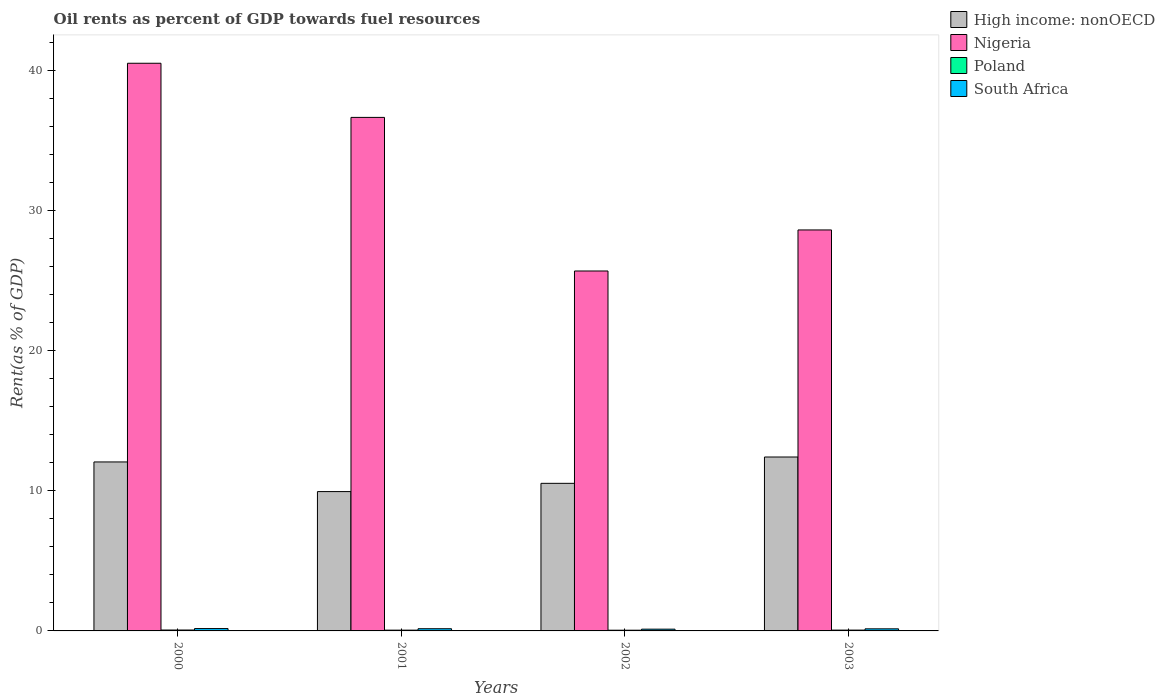How many different coloured bars are there?
Keep it short and to the point. 4. How many bars are there on the 4th tick from the left?
Make the answer very short. 4. How many bars are there on the 1st tick from the right?
Your answer should be compact. 4. In how many cases, is the number of bars for a given year not equal to the number of legend labels?
Your response must be concise. 0. What is the oil rent in South Africa in 2000?
Offer a terse response. 0.17. Across all years, what is the maximum oil rent in Nigeria?
Ensure brevity in your answer.  40.49. Across all years, what is the minimum oil rent in Poland?
Make the answer very short. 0.05. In which year was the oil rent in High income: nonOECD minimum?
Provide a succinct answer. 2001. What is the total oil rent in Nigeria in the graph?
Ensure brevity in your answer.  131.39. What is the difference between the oil rent in South Africa in 2001 and that in 2002?
Your response must be concise. 0.03. What is the difference between the oil rent in South Africa in 2000 and the oil rent in High income: nonOECD in 2001?
Offer a very short reply. -9.77. What is the average oil rent in Nigeria per year?
Provide a short and direct response. 32.85. In the year 2003, what is the difference between the oil rent in High income: nonOECD and oil rent in Poland?
Your response must be concise. 12.35. In how many years, is the oil rent in Nigeria greater than 38 %?
Your answer should be very brief. 1. What is the ratio of the oil rent in South Africa in 2001 to that in 2003?
Give a very brief answer. 1.05. Is the oil rent in Poland in 2002 less than that in 2003?
Your response must be concise. Yes. What is the difference between the highest and the second highest oil rent in South Africa?
Provide a short and direct response. 0.01. What is the difference between the highest and the lowest oil rent in South Africa?
Provide a short and direct response. 0.04. In how many years, is the oil rent in South Africa greater than the average oil rent in South Africa taken over all years?
Your answer should be very brief. 2. Is the sum of the oil rent in Poland in 2000 and 2001 greater than the maximum oil rent in Nigeria across all years?
Your answer should be compact. No. What does the 1st bar from the left in 2001 represents?
Provide a short and direct response. High income: nonOECD. Is it the case that in every year, the sum of the oil rent in South Africa and oil rent in High income: nonOECD is greater than the oil rent in Poland?
Your answer should be very brief. Yes. How many years are there in the graph?
Make the answer very short. 4. What is the difference between two consecutive major ticks on the Y-axis?
Your answer should be very brief. 10. Are the values on the major ticks of Y-axis written in scientific E-notation?
Offer a terse response. No. How many legend labels are there?
Make the answer very short. 4. What is the title of the graph?
Provide a short and direct response. Oil rents as percent of GDP towards fuel resources. What is the label or title of the Y-axis?
Offer a terse response. Rent(as % of GDP). What is the Rent(as % of GDP) of High income: nonOECD in 2000?
Give a very brief answer. 12.05. What is the Rent(as % of GDP) in Nigeria in 2000?
Give a very brief answer. 40.49. What is the Rent(as % of GDP) of Poland in 2000?
Offer a very short reply. 0.06. What is the Rent(as % of GDP) in South Africa in 2000?
Offer a terse response. 0.17. What is the Rent(as % of GDP) of High income: nonOECD in 2001?
Provide a succinct answer. 9.94. What is the Rent(as % of GDP) in Nigeria in 2001?
Provide a succinct answer. 36.63. What is the Rent(as % of GDP) in Poland in 2001?
Offer a very short reply. 0.05. What is the Rent(as % of GDP) of South Africa in 2001?
Your answer should be very brief. 0.16. What is the Rent(as % of GDP) of High income: nonOECD in 2002?
Offer a very short reply. 10.53. What is the Rent(as % of GDP) in Nigeria in 2002?
Offer a terse response. 25.67. What is the Rent(as % of GDP) in Poland in 2002?
Provide a succinct answer. 0.05. What is the Rent(as % of GDP) in South Africa in 2002?
Your answer should be very brief. 0.13. What is the Rent(as % of GDP) in High income: nonOECD in 2003?
Your answer should be very brief. 12.4. What is the Rent(as % of GDP) in Nigeria in 2003?
Your answer should be very brief. 28.6. What is the Rent(as % of GDP) of Poland in 2003?
Offer a very short reply. 0.06. What is the Rent(as % of GDP) in South Africa in 2003?
Your answer should be compact. 0.15. Across all years, what is the maximum Rent(as % of GDP) in High income: nonOECD?
Keep it short and to the point. 12.4. Across all years, what is the maximum Rent(as % of GDP) in Nigeria?
Provide a short and direct response. 40.49. Across all years, what is the maximum Rent(as % of GDP) of Poland?
Ensure brevity in your answer.  0.06. Across all years, what is the maximum Rent(as % of GDP) in South Africa?
Provide a succinct answer. 0.17. Across all years, what is the minimum Rent(as % of GDP) in High income: nonOECD?
Provide a succinct answer. 9.94. Across all years, what is the minimum Rent(as % of GDP) of Nigeria?
Give a very brief answer. 25.67. Across all years, what is the minimum Rent(as % of GDP) of Poland?
Your answer should be very brief. 0.05. Across all years, what is the minimum Rent(as % of GDP) of South Africa?
Provide a short and direct response. 0.13. What is the total Rent(as % of GDP) of High income: nonOECD in the graph?
Your answer should be very brief. 44.92. What is the total Rent(as % of GDP) in Nigeria in the graph?
Your response must be concise. 131.39. What is the total Rent(as % of GDP) in Poland in the graph?
Make the answer very short. 0.23. What is the total Rent(as % of GDP) of South Africa in the graph?
Your answer should be compact. 0.6. What is the difference between the Rent(as % of GDP) of High income: nonOECD in 2000 and that in 2001?
Offer a very short reply. 2.11. What is the difference between the Rent(as % of GDP) of Nigeria in 2000 and that in 2001?
Give a very brief answer. 3.86. What is the difference between the Rent(as % of GDP) of Poland in 2000 and that in 2001?
Your answer should be very brief. 0.01. What is the difference between the Rent(as % of GDP) in South Africa in 2000 and that in 2001?
Provide a short and direct response. 0.01. What is the difference between the Rent(as % of GDP) in High income: nonOECD in 2000 and that in 2002?
Your response must be concise. 1.53. What is the difference between the Rent(as % of GDP) in Nigeria in 2000 and that in 2002?
Offer a very short reply. 14.82. What is the difference between the Rent(as % of GDP) in Poland in 2000 and that in 2002?
Your answer should be compact. 0.01. What is the difference between the Rent(as % of GDP) of South Africa in 2000 and that in 2002?
Ensure brevity in your answer.  0.04. What is the difference between the Rent(as % of GDP) of High income: nonOECD in 2000 and that in 2003?
Provide a short and direct response. -0.35. What is the difference between the Rent(as % of GDP) in Nigeria in 2000 and that in 2003?
Offer a terse response. 11.89. What is the difference between the Rent(as % of GDP) in Poland in 2000 and that in 2003?
Provide a succinct answer. 0.01. What is the difference between the Rent(as % of GDP) of South Africa in 2000 and that in 2003?
Keep it short and to the point. 0.02. What is the difference between the Rent(as % of GDP) of High income: nonOECD in 2001 and that in 2002?
Your answer should be very brief. -0.59. What is the difference between the Rent(as % of GDP) in Nigeria in 2001 and that in 2002?
Ensure brevity in your answer.  10.95. What is the difference between the Rent(as % of GDP) in Poland in 2001 and that in 2002?
Provide a short and direct response. 0. What is the difference between the Rent(as % of GDP) in South Africa in 2001 and that in 2002?
Keep it short and to the point. 0.03. What is the difference between the Rent(as % of GDP) in High income: nonOECD in 2001 and that in 2003?
Ensure brevity in your answer.  -2.47. What is the difference between the Rent(as % of GDP) in Nigeria in 2001 and that in 2003?
Give a very brief answer. 8.03. What is the difference between the Rent(as % of GDP) in Poland in 2001 and that in 2003?
Ensure brevity in your answer.  -0. What is the difference between the Rent(as % of GDP) of South Africa in 2001 and that in 2003?
Provide a short and direct response. 0.01. What is the difference between the Rent(as % of GDP) in High income: nonOECD in 2002 and that in 2003?
Your response must be concise. -1.88. What is the difference between the Rent(as % of GDP) of Nigeria in 2002 and that in 2003?
Ensure brevity in your answer.  -2.93. What is the difference between the Rent(as % of GDP) of Poland in 2002 and that in 2003?
Your answer should be compact. -0.01. What is the difference between the Rent(as % of GDP) in South Africa in 2002 and that in 2003?
Your response must be concise. -0.02. What is the difference between the Rent(as % of GDP) in High income: nonOECD in 2000 and the Rent(as % of GDP) in Nigeria in 2001?
Your answer should be very brief. -24.57. What is the difference between the Rent(as % of GDP) of High income: nonOECD in 2000 and the Rent(as % of GDP) of Poland in 2001?
Provide a short and direct response. 12. What is the difference between the Rent(as % of GDP) in High income: nonOECD in 2000 and the Rent(as % of GDP) in South Africa in 2001?
Make the answer very short. 11.9. What is the difference between the Rent(as % of GDP) in Nigeria in 2000 and the Rent(as % of GDP) in Poland in 2001?
Your answer should be compact. 40.43. What is the difference between the Rent(as % of GDP) in Nigeria in 2000 and the Rent(as % of GDP) in South Africa in 2001?
Keep it short and to the point. 40.33. What is the difference between the Rent(as % of GDP) of Poland in 2000 and the Rent(as % of GDP) of South Africa in 2001?
Provide a short and direct response. -0.09. What is the difference between the Rent(as % of GDP) of High income: nonOECD in 2000 and the Rent(as % of GDP) of Nigeria in 2002?
Your answer should be compact. -13.62. What is the difference between the Rent(as % of GDP) in High income: nonOECD in 2000 and the Rent(as % of GDP) in Poland in 2002?
Provide a succinct answer. 12. What is the difference between the Rent(as % of GDP) in High income: nonOECD in 2000 and the Rent(as % of GDP) in South Africa in 2002?
Your response must be concise. 11.93. What is the difference between the Rent(as % of GDP) of Nigeria in 2000 and the Rent(as % of GDP) of Poland in 2002?
Provide a succinct answer. 40.44. What is the difference between the Rent(as % of GDP) of Nigeria in 2000 and the Rent(as % of GDP) of South Africa in 2002?
Provide a short and direct response. 40.36. What is the difference between the Rent(as % of GDP) of Poland in 2000 and the Rent(as % of GDP) of South Africa in 2002?
Offer a very short reply. -0.06. What is the difference between the Rent(as % of GDP) in High income: nonOECD in 2000 and the Rent(as % of GDP) in Nigeria in 2003?
Your answer should be compact. -16.55. What is the difference between the Rent(as % of GDP) of High income: nonOECD in 2000 and the Rent(as % of GDP) of Poland in 2003?
Make the answer very short. 11.99. What is the difference between the Rent(as % of GDP) of High income: nonOECD in 2000 and the Rent(as % of GDP) of South Africa in 2003?
Offer a very short reply. 11.9. What is the difference between the Rent(as % of GDP) of Nigeria in 2000 and the Rent(as % of GDP) of Poland in 2003?
Your answer should be compact. 40.43. What is the difference between the Rent(as % of GDP) in Nigeria in 2000 and the Rent(as % of GDP) in South Africa in 2003?
Offer a terse response. 40.34. What is the difference between the Rent(as % of GDP) of Poland in 2000 and the Rent(as % of GDP) of South Africa in 2003?
Ensure brevity in your answer.  -0.09. What is the difference between the Rent(as % of GDP) in High income: nonOECD in 2001 and the Rent(as % of GDP) in Nigeria in 2002?
Offer a terse response. -15.73. What is the difference between the Rent(as % of GDP) of High income: nonOECD in 2001 and the Rent(as % of GDP) of Poland in 2002?
Give a very brief answer. 9.89. What is the difference between the Rent(as % of GDP) of High income: nonOECD in 2001 and the Rent(as % of GDP) of South Africa in 2002?
Provide a succinct answer. 9.81. What is the difference between the Rent(as % of GDP) of Nigeria in 2001 and the Rent(as % of GDP) of Poland in 2002?
Offer a very short reply. 36.58. What is the difference between the Rent(as % of GDP) of Nigeria in 2001 and the Rent(as % of GDP) of South Africa in 2002?
Provide a succinct answer. 36.5. What is the difference between the Rent(as % of GDP) of Poland in 2001 and the Rent(as % of GDP) of South Africa in 2002?
Give a very brief answer. -0.07. What is the difference between the Rent(as % of GDP) of High income: nonOECD in 2001 and the Rent(as % of GDP) of Nigeria in 2003?
Provide a succinct answer. -18.66. What is the difference between the Rent(as % of GDP) of High income: nonOECD in 2001 and the Rent(as % of GDP) of Poland in 2003?
Offer a very short reply. 9.88. What is the difference between the Rent(as % of GDP) in High income: nonOECD in 2001 and the Rent(as % of GDP) in South Africa in 2003?
Provide a succinct answer. 9.79. What is the difference between the Rent(as % of GDP) in Nigeria in 2001 and the Rent(as % of GDP) in Poland in 2003?
Give a very brief answer. 36.57. What is the difference between the Rent(as % of GDP) in Nigeria in 2001 and the Rent(as % of GDP) in South Africa in 2003?
Your answer should be very brief. 36.48. What is the difference between the Rent(as % of GDP) of Poland in 2001 and the Rent(as % of GDP) of South Africa in 2003?
Provide a short and direct response. -0.09. What is the difference between the Rent(as % of GDP) of High income: nonOECD in 2002 and the Rent(as % of GDP) of Nigeria in 2003?
Your answer should be compact. -18.07. What is the difference between the Rent(as % of GDP) in High income: nonOECD in 2002 and the Rent(as % of GDP) in Poland in 2003?
Provide a short and direct response. 10.47. What is the difference between the Rent(as % of GDP) in High income: nonOECD in 2002 and the Rent(as % of GDP) in South Africa in 2003?
Your answer should be compact. 10.38. What is the difference between the Rent(as % of GDP) of Nigeria in 2002 and the Rent(as % of GDP) of Poland in 2003?
Your answer should be compact. 25.61. What is the difference between the Rent(as % of GDP) in Nigeria in 2002 and the Rent(as % of GDP) in South Africa in 2003?
Provide a succinct answer. 25.52. What is the difference between the Rent(as % of GDP) of Poland in 2002 and the Rent(as % of GDP) of South Africa in 2003?
Your answer should be compact. -0.1. What is the average Rent(as % of GDP) in High income: nonOECD per year?
Your answer should be very brief. 11.23. What is the average Rent(as % of GDP) of Nigeria per year?
Ensure brevity in your answer.  32.85. What is the average Rent(as % of GDP) in Poland per year?
Offer a very short reply. 0.06. What is the average Rent(as % of GDP) of South Africa per year?
Your answer should be very brief. 0.15. In the year 2000, what is the difference between the Rent(as % of GDP) of High income: nonOECD and Rent(as % of GDP) of Nigeria?
Offer a very short reply. -28.44. In the year 2000, what is the difference between the Rent(as % of GDP) in High income: nonOECD and Rent(as % of GDP) in Poland?
Your response must be concise. 11.99. In the year 2000, what is the difference between the Rent(as % of GDP) of High income: nonOECD and Rent(as % of GDP) of South Africa?
Keep it short and to the point. 11.88. In the year 2000, what is the difference between the Rent(as % of GDP) of Nigeria and Rent(as % of GDP) of Poland?
Offer a terse response. 40.42. In the year 2000, what is the difference between the Rent(as % of GDP) in Nigeria and Rent(as % of GDP) in South Africa?
Ensure brevity in your answer.  40.32. In the year 2000, what is the difference between the Rent(as % of GDP) in Poland and Rent(as % of GDP) in South Africa?
Provide a succinct answer. -0.1. In the year 2001, what is the difference between the Rent(as % of GDP) of High income: nonOECD and Rent(as % of GDP) of Nigeria?
Give a very brief answer. -26.69. In the year 2001, what is the difference between the Rent(as % of GDP) of High income: nonOECD and Rent(as % of GDP) of Poland?
Provide a short and direct response. 9.88. In the year 2001, what is the difference between the Rent(as % of GDP) in High income: nonOECD and Rent(as % of GDP) in South Africa?
Your answer should be very brief. 9.78. In the year 2001, what is the difference between the Rent(as % of GDP) in Nigeria and Rent(as % of GDP) in Poland?
Offer a very short reply. 36.57. In the year 2001, what is the difference between the Rent(as % of GDP) of Nigeria and Rent(as % of GDP) of South Africa?
Your response must be concise. 36.47. In the year 2001, what is the difference between the Rent(as % of GDP) of Poland and Rent(as % of GDP) of South Africa?
Keep it short and to the point. -0.1. In the year 2002, what is the difference between the Rent(as % of GDP) of High income: nonOECD and Rent(as % of GDP) of Nigeria?
Give a very brief answer. -15.15. In the year 2002, what is the difference between the Rent(as % of GDP) in High income: nonOECD and Rent(as % of GDP) in Poland?
Give a very brief answer. 10.48. In the year 2002, what is the difference between the Rent(as % of GDP) of High income: nonOECD and Rent(as % of GDP) of South Africa?
Your answer should be compact. 10.4. In the year 2002, what is the difference between the Rent(as % of GDP) of Nigeria and Rent(as % of GDP) of Poland?
Provide a short and direct response. 25.62. In the year 2002, what is the difference between the Rent(as % of GDP) in Nigeria and Rent(as % of GDP) in South Africa?
Offer a very short reply. 25.55. In the year 2002, what is the difference between the Rent(as % of GDP) in Poland and Rent(as % of GDP) in South Africa?
Your response must be concise. -0.07. In the year 2003, what is the difference between the Rent(as % of GDP) of High income: nonOECD and Rent(as % of GDP) of Nigeria?
Give a very brief answer. -16.19. In the year 2003, what is the difference between the Rent(as % of GDP) in High income: nonOECD and Rent(as % of GDP) in Poland?
Offer a terse response. 12.35. In the year 2003, what is the difference between the Rent(as % of GDP) in High income: nonOECD and Rent(as % of GDP) in South Africa?
Provide a short and direct response. 12.26. In the year 2003, what is the difference between the Rent(as % of GDP) in Nigeria and Rent(as % of GDP) in Poland?
Offer a very short reply. 28.54. In the year 2003, what is the difference between the Rent(as % of GDP) of Nigeria and Rent(as % of GDP) of South Africa?
Provide a succinct answer. 28.45. In the year 2003, what is the difference between the Rent(as % of GDP) in Poland and Rent(as % of GDP) in South Africa?
Offer a terse response. -0.09. What is the ratio of the Rent(as % of GDP) of High income: nonOECD in 2000 to that in 2001?
Your answer should be compact. 1.21. What is the ratio of the Rent(as % of GDP) in Nigeria in 2000 to that in 2001?
Provide a succinct answer. 1.11. What is the ratio of the Rent(as % of GDP) in Poland in 2000 to that in 2001?
Offer a very short reply. 1.16. What is the ratio of the Rent(as % of GDP) of South Africa in 2000 to that in 2001?
Your response must be concise. 1.07. What is the ratio of the Rent(as % of GDP) in High income: nonOECD in 2000 to that in 2002?
Your response must be concise. 1.14. What is the ratio of the Rent(as % of GDP) of Nigeria in 2000 to that in 2002?
Offer a very short reply. 1.58. What is the ratio of the Rent(as % of GDP) of Poland in 2000 to that in 2002?
Make the answer very short. 1.25. What is the ratio of the Rent(as % of GDP) in South Africa in 2000 to that in 2002?
Your answer should be compact. 1.34. What is the ratio of the Rent(as % of GDP) of High income: nonOECD in 2000 to that in 2003?
Your answer should be compact. 0.97. What is the ratio of the Rent(as % of GDP) of Nigeria in 2000 to that in 2003?
Provide a succinct answer. 1.42. What is the ratio of the Rent(as % of GDP) in Poland in 2000 to that in 2003?
Ensure brevity in your answer.  1.09. What is the ratio of the Rent(as % of GDP) of South Africa in 2000 to that in 2003?
Make the answer very short. 1.13. What is the ratio of the Rent(as % of GDP) of High income: nonOECD in 2001 to that in 2002?
Your answer should be very brief. 0.94. What is the ratio of the Rent(as % of GDP) in Nigeria in 2001 to that in 2002?
Make the answer very short. 1.43. What is the ratio of the Rent(as % of GDP) of Poland in 2001 to that in 2002?
Your answer should be very brief. 1.08. What is the ratio of the Rent(as % of GDP) in South Africa in 2001 to that in 2002?
Your answer should be compact. 1.25. What is the ratio of the Rent(as % of GDP) of High income: nonOECD in 2001 to that in 2003?
Offer a terse response. 0.8. What is the ratio of the Rent(as % of GDP) of Nigeria in 2001 to that in 2003?
Offer a very short reply. 1.28. What is the ratio of the Rent(as % of GDP) of Poland in 2001 to that in 2003?
Your response must be concise. 0.94. What is the ratio of the Rent(as % of GDP) in South Africa in 2001 to that in 2003?
Ensure brevity in your answer.  1.05. What is the ratio of the Rent(as % of GDP) of High income: nonOECD in 2002 to that in 2003?
Keep it short and to the point. 0.85. What is the ratio of the Rent(as % of GDP) in Nigeria in 2002 to that in 2003?
Your answer should be compact. 0.9. What is the ratio of the Rent(as % of GDP) of Poland in 2002 to that in 2003?
Your response must be concise. 0.87. What is the ratio of the Rent(as % of GDP) in South Africa in 2002 to that in 2003?
Offer a very short reply. 0.84. What is the difference between the highest and the second highest Rent(as % of GDP) in High income: nonOECD?
Your answer should be very brief. 0.35. What is the difference between the highest and the second highest Rent(as % of GDP) of Nigeria?
Your answer should be compact. 3.86. What is the difference between the highest and the second highest Rent(as % of GDP) of Poland?
Offer a terse response. 0.01. What is the difference between the highest and the second highest Rent(as % of GDP) of South Africa?
Your answer should be very brief. 0.01. What is the difference between the highest and the lowest Rent(as % of GDP) in High income: nonOECD?
Your answer should be compact. 2.47. What is the difference between the highest and the lowest Rent(as % of GDP) in Nigeria?
Make the answer very short. 14.82. What is the difference between the highest and the lowest Rent(as % of GDP) of Poland?
Provide a succinct answer. 0.01. What is the difference between the highest and the lowest Rent(as % of GDP) of South Africa?
Offer a terse response. 0.04. 